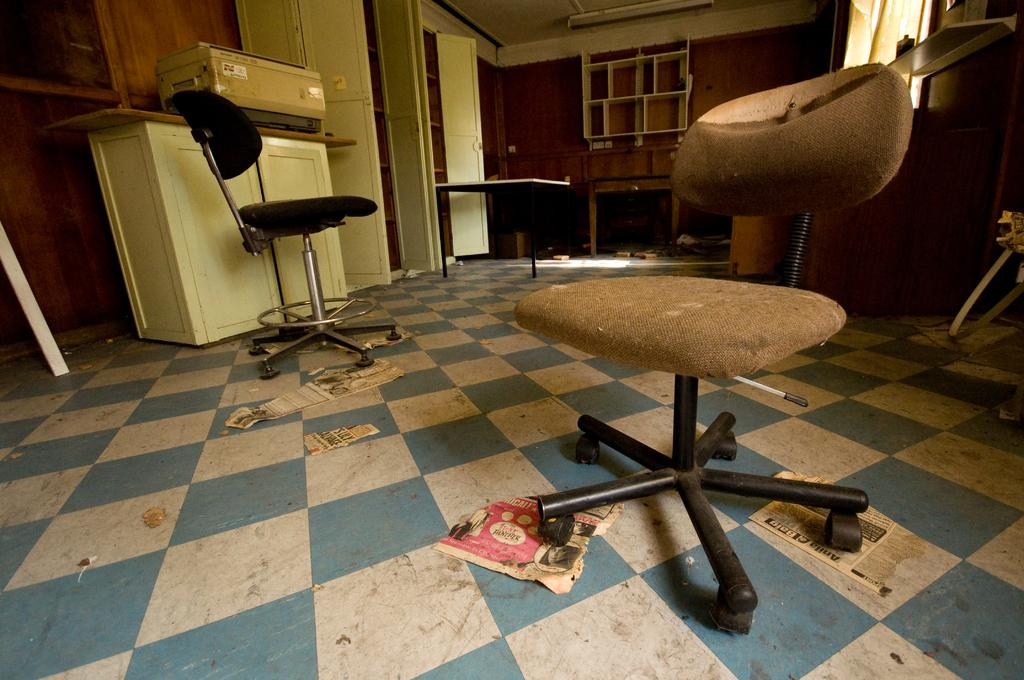What type of furniture is present on the floor in the image? There are two chairs on the floor. What type of beast can be seen sitting on the chairs in the image? There is no beast present in the image; only the two chairs are visible. What type of secretary is working at the desk in the image? There is no desk or secretary present in the image; only the two chairs are visible. 